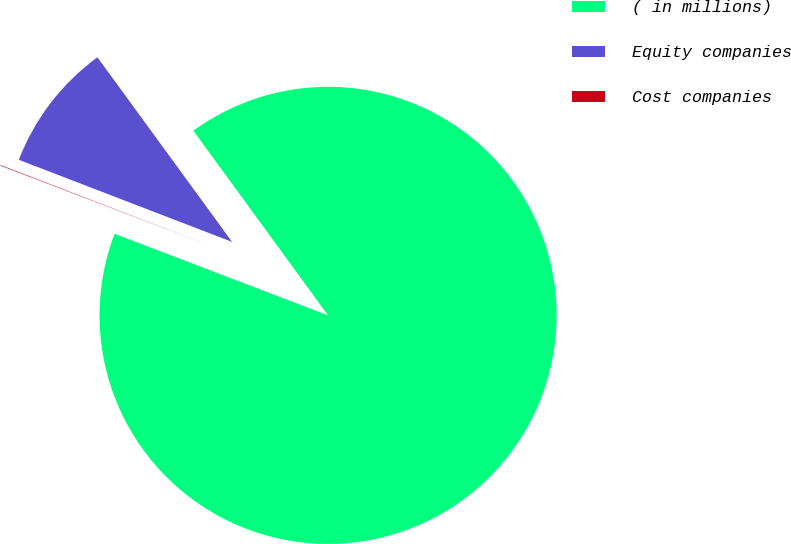Convert chart. <chart><loc_0><loc_0><loc_500><loc_500><pie_chart><fcel>( in millions)<fcel>Equity companies<fcel>Cost companies<nl><fcel>90.85%<fcel>9.12%<fcel>0.04%<nl></chart> 